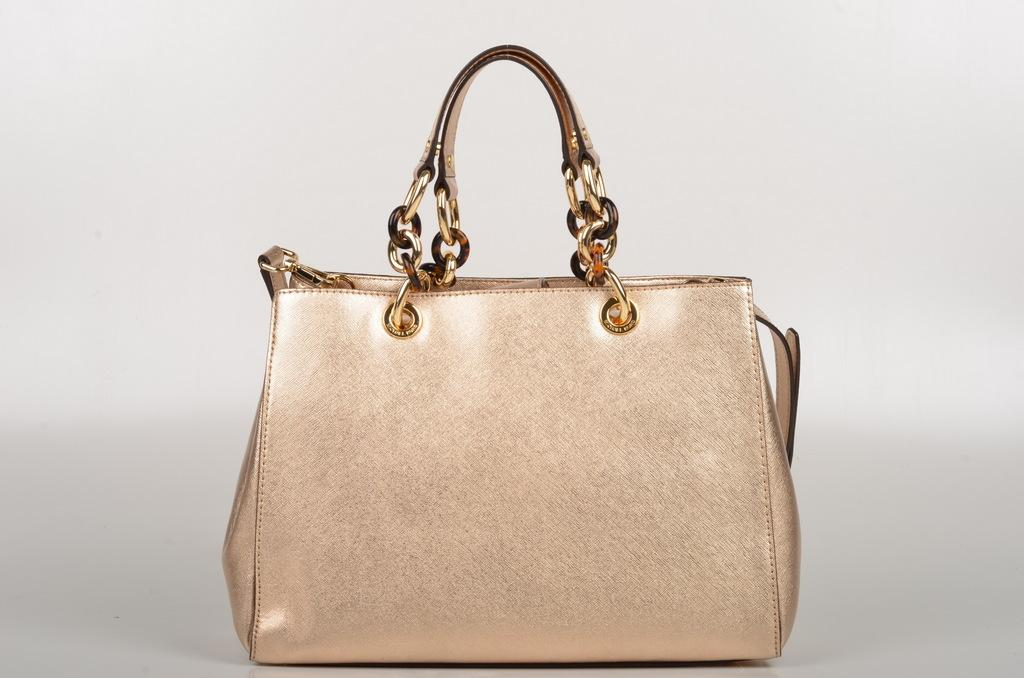What object can be seen in the image? There is a bag in the image. What feature is associated with the bag? There is a handle with a belt in the image. What news is being taught under the shade in the image? There is no news or shade present in the image; it only features a bag with a handle and belt. 